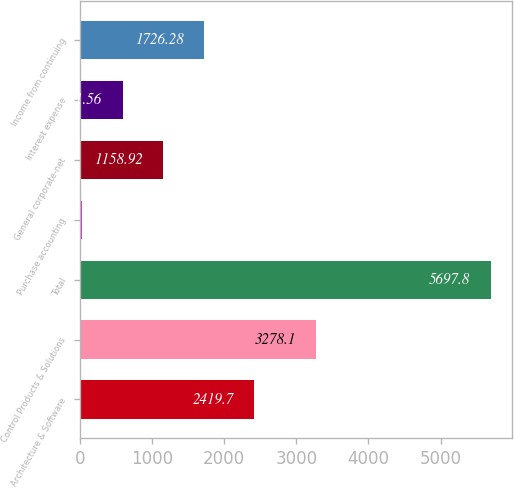Convert chart. <chart><loc_0><loc_0><loc_500><loc_500><bar_chart><fcel>Architecture & Software<fcel>Control Products & Solutions<fcel>Total<fcel>Purchase accounting<fcel>General corporate-net<fcel>Interest expense<fcel>Income from continuing<nl><fcel>2419.7<fcel>3278.1<fcel>5697.8<fcel>24.2<fcel>1158.92<fcel>591.56<fcel>1726.28<nl></chart> 